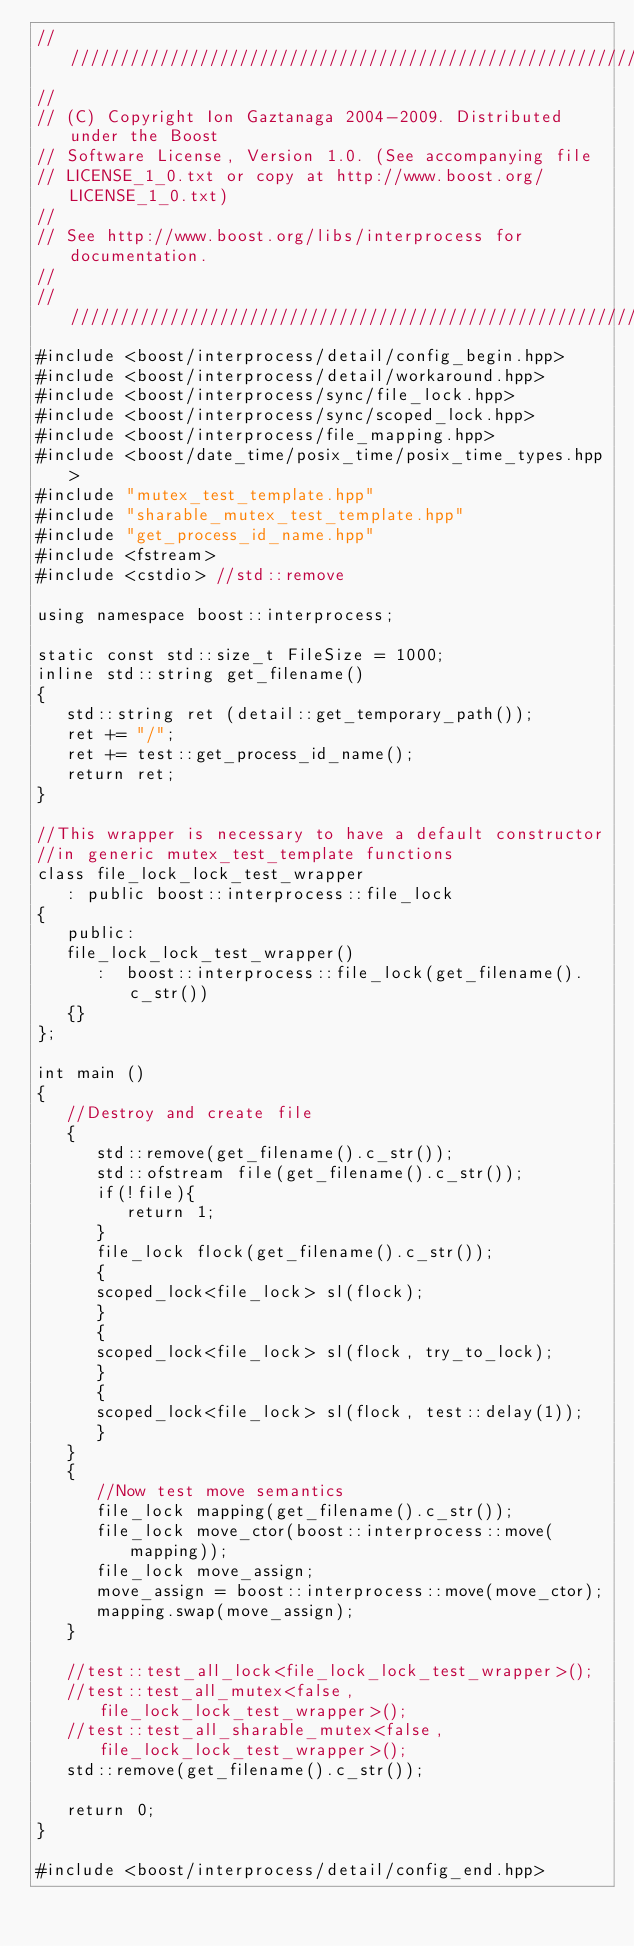Convert code to text. <code><loc_0><loc_0><loc_500><loc_500><_C++_>//////////////////////////////////////////////////////////////////////////////
//
// (C) Copyright Ion Gaztanaga 2004-2009. Distributed under the Boost
// Software License, Version 1.0. (See accompanying file
// LICENSE_1_0.txt or copy at http://www.boost.org/LICENSE_1_0.txt)
//
// See http://www.boost.org/libs/interprocess for documentation.
//
//////////////////////////////////////////////////////////////////////////////
#include <boost/interprocess/detail/config_begin.hpp>
#include <boost/interprocess/detail/workaround.hpp>
#include <boost/interprocess/sync/file_lock.hpp>
#include <boost/interprocess/sync/scoped_lock.hpp>
#include <boost/interprocess/file_mapping.hpp>
#include <boost/date_time/posix_time/posix_time_types.hpp>
#include "mutex_test_template.hpp"
#include "sharable_mutex_test_template.hpp"
#include "get_process_id_name.hpp"
#include <fstream>
#include <cstdio> //std::remove

using namespace boost::interprocess;

static const std::size_t FileSize = 1000;
inline std::string get_filename()
{
   std::string ret (detail::get_temporary_path());
   ret += "/";
   ret += test::get_process_id_name();
   return ret;
}

//This wrapper is necessary to have a default constructor
//in generic mutex_test_template functions
class file_lock_lock_test_wrapper
   : public boost::interprocess::file_lock
{
   public:
   file_lock_lock_test_wrapper()
      :  boost::interprocess::file_lock(get_filename().c_str())
   {}
};

int main ()
{
   //Destroy and create file
   {
      std::remove(get_filename().c_str());
      std::ofstream file(get_filename().c_str());
      if(!file){
         return 1;
      }
      file_lock flock(get_filename().c_str());
      {
      scoped_lock<file_lock> sl(flock);
      }
      {
      scoped_lock<file_lock> sl(flock, try_to_lock);
      }
      {
      scoped_lock<file_lock> sl(flock, test::delay(1));
      }
   }
   {
      //Now test move semantics
      file_lock mapping(get_filename().c_str());
      file_lock move_ctor(boost::interprocess::move(mapping));
      file_lock move_assign;
      move_assign = boost::interprocess::move(move_ctor);
      mapping.swap(move_assign);
   }

   //test::test_all_lock<file_lock_lock_test_wrapper>();
   //test::test_all_mutex<false, file_lock_lock_test_wrapper>();
   //test::test_all_sharable_mutex<false, file_lock_lock_test_wrapper>();
   std::remove(get_filename().c_str());

   return 0;
}

#include <boost/interprocess/detail/config_end.hpp>
</code> 